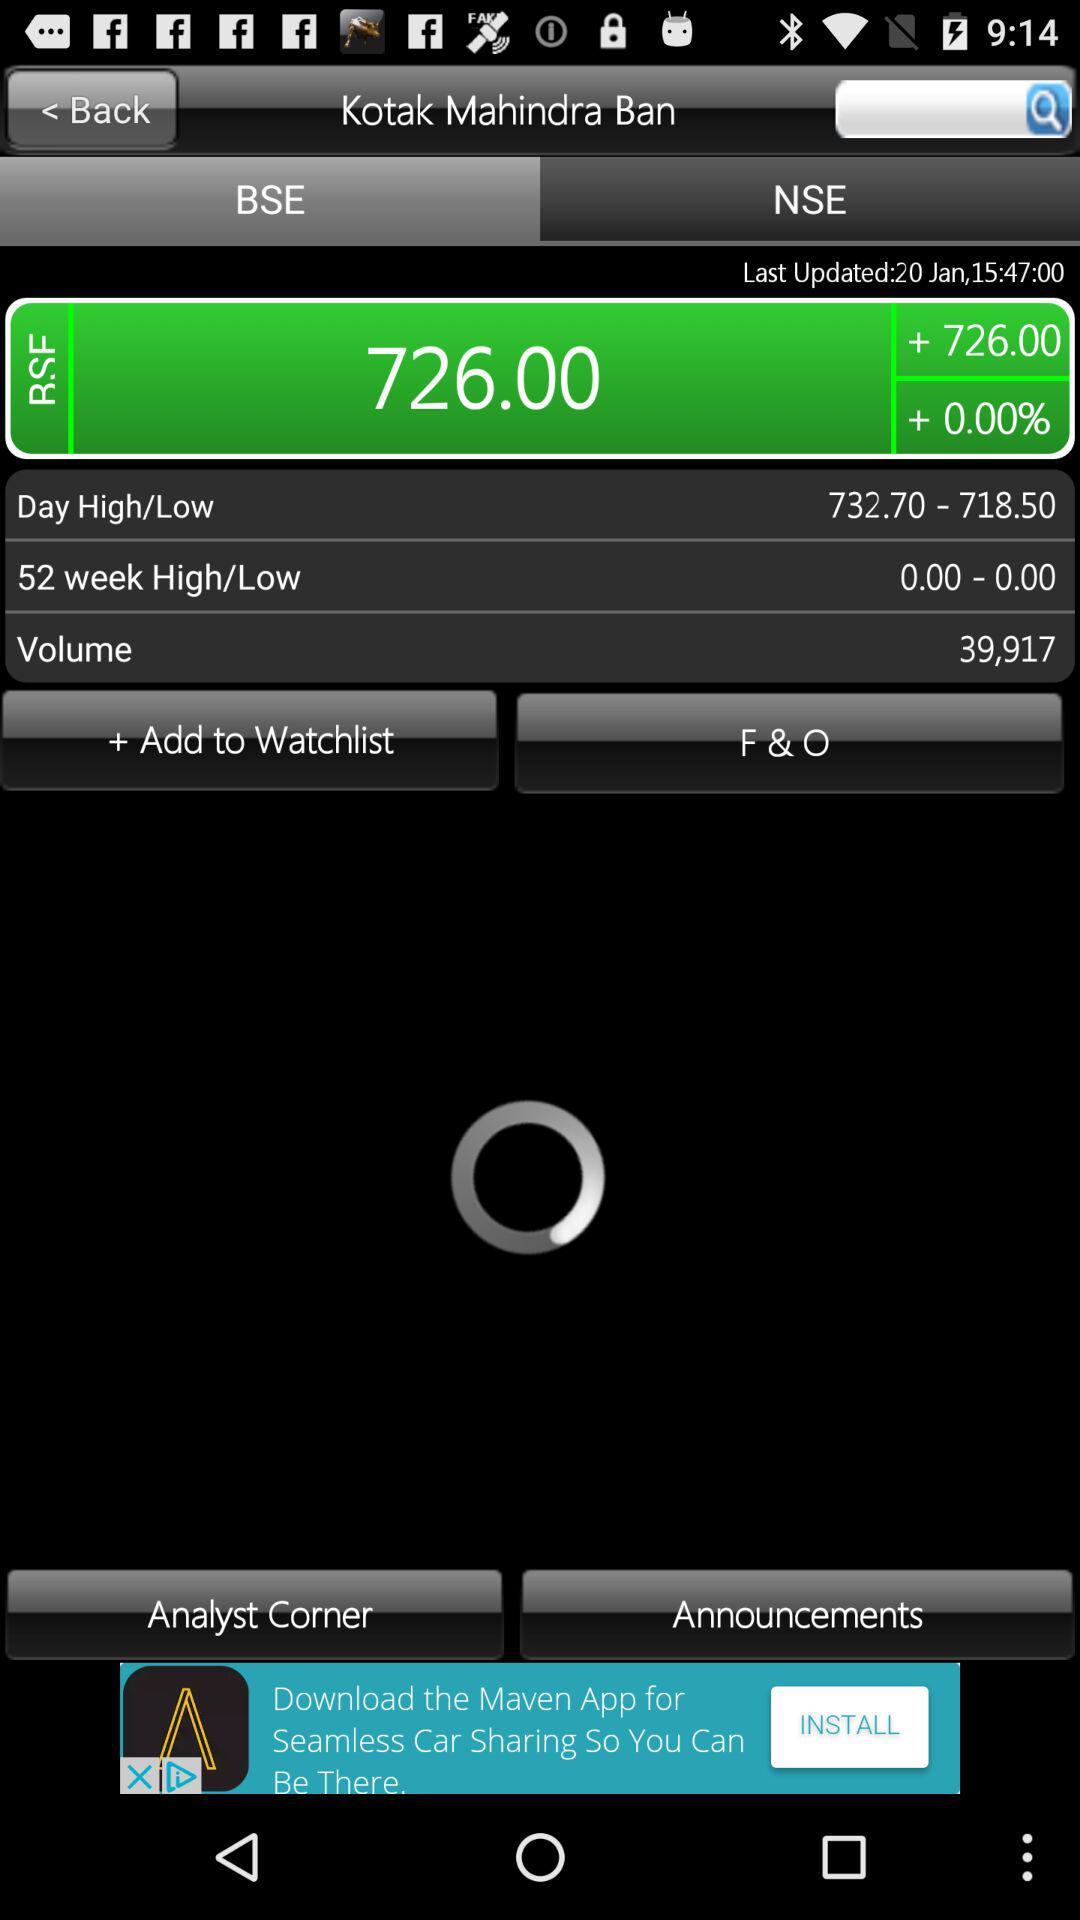What is the volume? The volume is 39,917. 